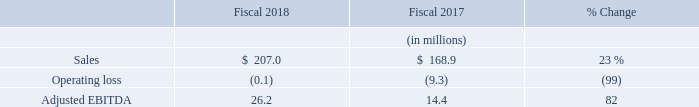Cubic Mission Solutions
Sales: CMS sales increased 23% to $207.0 million in fiscal 2018 compared to $168.9 million in 2017. The increase in sales was primarily due to increased orders and shipments of expeditionary satellite communications products, tactical networking products, and Command and Control, Intelligence, Surveillance and Reconnaissance (C2ISR) products and services. Businesses acquired during fiscal years 2018 and 2017 whose operations are included in our CMS operating segment had sales of $5.6 million and $1.5 million for fiscal years 2018 and 2017, respectively.
Amortization of Purchased Intangibles: Amortization of purchased intangibles included in the CMS results amounted to $20.8 million in 2018 and $23.6 million in 2017. The $2.8 million decrease in amortization expense is related to purchased intangible assets that are amortized based upon accelerated methods.
Operating Income: CMS had an operating loss of $0.1 million in 2018 compared to $9.3 million in 2017. CMS realized increased profits from expeditionary satellite communications products, tactical networking products, and C2ISR products and services. As mentioned above, amortization of purchased intangibles decreased to $20.8 million in 2018 compared to $23.6 million in 2017. CMS increased R&D expenditures between 2017 and 2018 by $10.8 million, primarily driven by development of new antenna technologies. Businesses acquired by CMS in fiscal years 2018 and 2017 incurred operating losses of $4.7 million in fiscal 2018 compared to $2.9 million in fiscal 2017. Included in the operating loss incurred by acquired businesses are acquisition transaction costs of $1.6 million and $1.8 million incurred in fiscal years 2018 and 2017, respectively.
Adjusted EBITDA: CMS Adjusted EBITDA increased 82% to $26.2 million in 2018 compared to $14.4 million in 2017.
The increase in CMS Adjusted EBITDA was primarily due to the same items described in the operating income section
above, excluding the changes in amortization expense and acquisition transaction costs discussed above as such items are
excluded from Adjusted EBITDA.
What is the percentage increase in CMS sales in 2018? 23%. What is the decrease in amortization expense related to? Purchased intangible assets that are amortized based upon accelerated methods. What did the increase in expeditionary satellite communications products, tactical networking products, C2ISR products and services result in? Increase in sales, increased profits. In which year is the amount of amortization of purchased intangibles included in the CMS results larger? 23.6>20.8
Answer: 2017. What is the change in sales in 2018?
Answer scale should be: million. 207.0-168.9
Answer: 38.1. What is the average adjusted EBITDA in 2018 and 2017?
Answer scale should be: million. (26.2+14.4)/2
Answer: 20.3. 